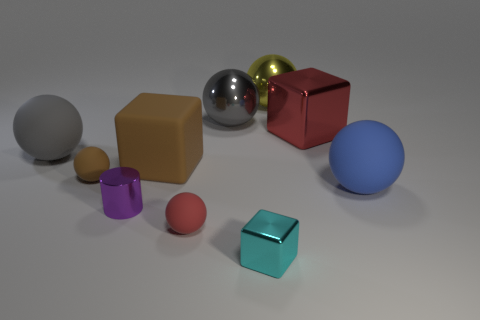What is the big red block made of?
Your answer should be very brief. Metal. How many other things are there of the same shape as the purple metallic object?
Provide a short and direct response. 0. Does the tiny brown matte object have the same shape as the small purple thing?
Offer a terse response. No. How many things are objects that are in front of the big blue rubber ball or matte balls to the left of the big blue object?
Ensure brevity in your answer.  5. How many objects are either green matte spheres or large gray things?
Ensure brevity in your answer.  2. There is a big matte ball behind the brown rubber ball; what number of gray rubber objects are right of it?
Make the answer very short. 0. How many other things are there of the same size as the cyan metal cube?
Provide a short and direct response. 3. What is the size of the ball that is the same color as the big matte block?
Offer a very short reply. Small. There is a big matte thing to the right of the cyan shiny block; does it have the same shape as the small brown matte object?
Give a very brief answer. Yes. What is the material of the gray ball on the right side of the big gray matte thing?
Give a very brief answer. Metal. 